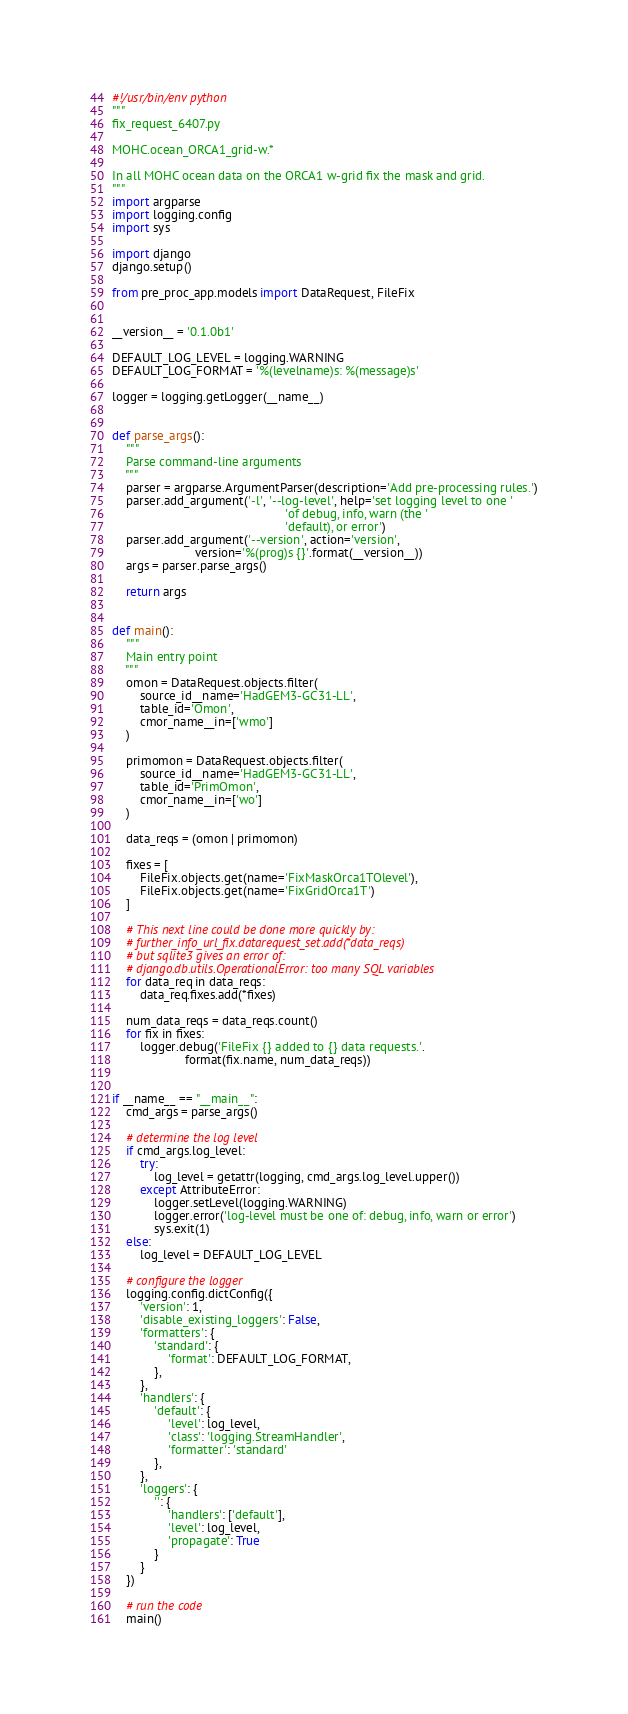Convert code to text. <code><loc_0><loc_0><loc_500><loc_500><_Python_>#!/usr/bin/env python
"""
fix_request_6407.py

MOHC.ocean_ORCA1_grid-w.*

In all MOHC ocean data on the ORCA1 w-grid fix the mask and grid.
"""
import argparse
import logging.config
import sys

import django
django.setup()

from pre_proc_app.models import DataRequest, FileFix


__version__ = '0.1.0b1'

DEFAULT_LOG_LEVEL = logging.WARNING
DEFAULT_LOG_FORMAT = '%(levelname)s: %(message)s'

logger = logging.getLogger(__name__)


def parse_args():
    """
    Parse command-line arguments
    """
    parser = argparse.ArgumentParser(description='Add pre-processing rules.')
    parser.add_argument('-l', '--log-level', help='set logging level to one '
                                                  'of debug, info, warn (the '
                                                  'default), or error')
    parser.add_argument('--version', action='version',
                        version='%(prog)s {}'.format(__version__))
    args = parser.parse_args()

    return args


def main():
    """
    Main entry point
    """
    omon = DataRequest.objects.filter(
        source_id__name='HadGEM3-GC31-LL',
        table_id='Omon',
        cmor_name__in=['wmo']
    )

    primomon = DataRequest.objects.filter(
        source_id__name='HadGEM3-GC31-LL',
        table_id='PrimOmon',
        cmor_name__in=['wo']
    )

    data_reqs = (omon | primomon)

    fixes = [
        FileFix.objects.get(name='FixMaskOrca1TOlevel'),
        FileFix.objects.get(name='FixGridOrca1T')
    ]

    # This next line could be done more quickly by:
    # further_info_url_fix.datarequest_set.add(*data_reqs)
    # but sqlite3 gives an error of:
    # django.db.utils.OperationalError: too many SQL variables
    for data_req in data_reqs:
        data_req.fixes.add(*fixes)

    num_data_reqs = data_reqs.count()
    for fix in fixes:
        logger.debug('FileFix {} added to {} data requests.'.
                     format(fix.name, num_data_reqs))


if __name__ == "__main__":
    cmd_args = parse_args()

    # determine the log level
    if cmd_args.log_level:
        try:
            log_level = getattr(logging, cmd_args.log_level.upper())
        except AttributeError:
            logger.setLevel(logging.WARNING)
            logger.error('log-level must be one of: debug, info, warn or error')
            sys.exit(1)
    else:
        log_level = DEFAULT_LOG_LEVEL

    # configure the logger
    logging.config.dictConfig({
        'version': 1,
        'disable_existing_loggers': False,
        'formatters': {
            'standard': {
                'format': DEFAULT_LOG_FORMAT,
            },
        },
        'handlers': {
            'default': {
                'level': log_level,
                'class': 'logging.StreamHandler',
                'formatter': 'standard'
            },
        },
        'loggers': {
            '': {
                'handlers': ['default'],
                'level': log_level,
                'propagate': True
            }
        }
    })

    # run the code
    main()
</code> 